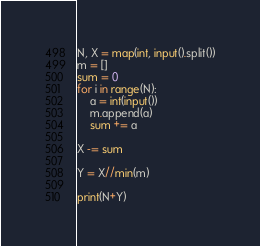<code> <loc_0><loc_0><loc_500><loc_500><_Python_>N, X = map(int, input().split())
m = []
sum = 0
for i in range(N):
    a = int(input())
    m.append(a)
    sum += a

X -= sum

Y = X//min(m)

print(N+Y)</code> 